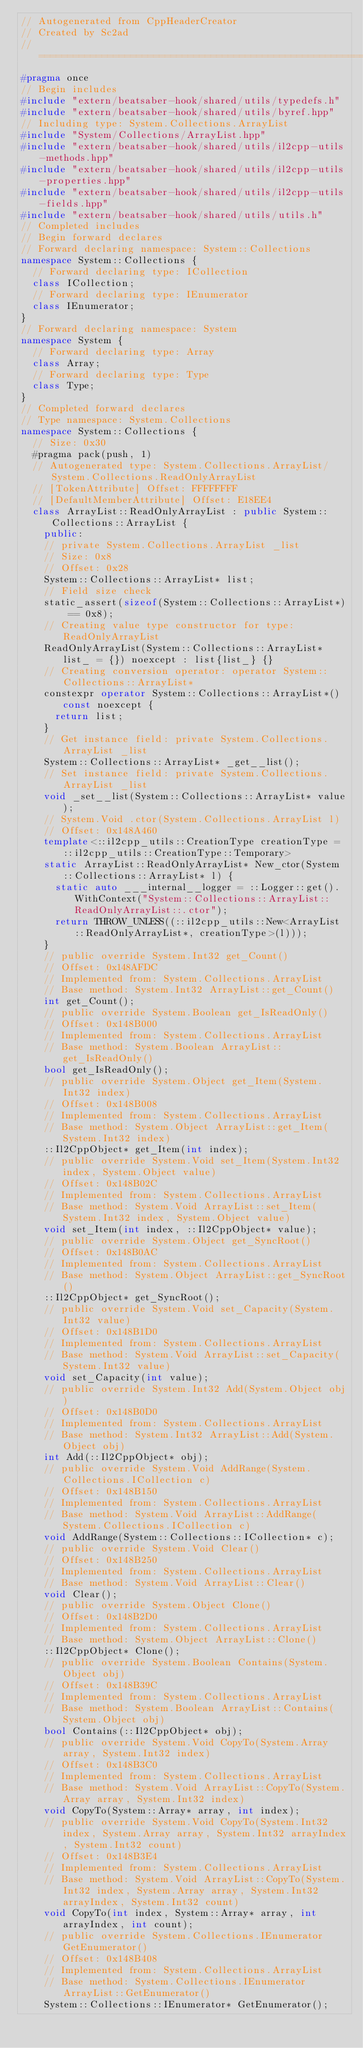Convert code to text. <code><loc_0><loc_0><loc_500><loc_500><_C++_>// Autogenerated from CppHeaderCreator
// Created by Sc2ad
// =========================================================================
#pragma once
// Begin includes
#include "extern/beatsaber-hook/shared/utils/typedefs.h"
#include "extern/beatsaber-hook/shared/utils/byref.hpp"
// Including type: System.Collections.ArrayList
#include "System/Collections/ArrayList.hpp"
#include "extern/beatsaber-hook/shared/utils/il2cpp-utils-methods.hpp"
#include "extern/beatsaber-hook/shared/utils/il2cpp-utils-properties.hpp"
#include "extern/beatsaber-hook/shared/utils/il2cpp-utils-fields.hpp"
#include "extern/beatsaber-hook/shared/utils/utils.h"
// Completed includes
// Begin forward declares
// Forward declaring namespace: System::Collections
namespace System::Collections {
  // Forward declaring type: ICollection
  class ICollection;
  // Forward declaring type: IEnumerator
  class IEnumerator;
}
// Forward declaring namespace: System
namespace System {
  // Forward declaring type: Array
  class Array;
  // Forward declaring type: Type
  class Type;
}
// Completed forward declares
// Type namespace: System.Collections
namespace System::Collections {
  // Size: 0x30
  #pragma pack(push, 1)
  // Autogenerated type: System.Collections.ArrayList/System.Collections.ReadOnlyArrayList
  // [TokenAttribute] Offset: FFFFFFFF
  // [DefaultMemberAttribute] Offset: E18EE4
  class ArrayList::ReadOnlyArrayList : public System::Collections::ArrayList {
    public:
    // private System.Collections.ArrayList _list
    // Size: 0x8
    // Offset: 0x28
    System::Collections::ArrayList* list;
    // Field size check
    static_assert(sizeof(System::Collections::ArrayList*) == 0x8);
    // Creating value type constructor for type: ReadOnlyArrayList
    ReadOnlyArrayList(System::Collections::ArrayList* list_ = {}) noexcept : list{list_} {}
    // Creating conversion operator: operator System::Collections::ArrayList*
    constexpr operator System::Collections::ArrayList*() const noexcept {
      return list;
    }
    // Get instance field: private System.Collections.ArrayList _list
    System::Collections::ArrayList* _get__list();
    // Set instance field: private System.Collections.ArrayList _list
    void _set__list(System::Collections::ArrayList* value);
    // System.Void .ctor(System.Collections.ArrayList l)
    // Offset: 0x148A460
    template<::il2cpp_utils::CreationType creationType = ::il2cpp_utils::CreationType::Temporary>
    static ArrayList::ReadOnlyArrayList* New_ctor(System::Collections::ArrayList* l) {
      static auto ___internal__logger = ::Logger::get().WithContext("System::Collections::ArrayList::ReadOnlyArrayList::.ctor");
      return THROW_UNLESS((::il2cpp_utils::New<ArrayList::ReadOnlyArrayList*, creationType>(l)));
    }
    // public override System.Int32 get_Count()
    // Offset: 0x148AFDC
    // Implemented from: System.Collections.ArrayList
    // Base method: System.Int32 ArrayList::get_Count()
    int get_Count();
    // public override System.Boolean get_IsReadOnly()
    // Offset: 0x148B000
    // Implemented from: System.Collections.ArrayList
    // Base method: System.Boolean ArrayList::get_IsReadOnly()
    bool get_IsReadOnly();
    // public override System.Object get_Item(System.Int32 index)
    // Offset: 0x148B008
    // Implemented from: System.Collections.ArrayList
    // Base method: System.Object ArrayList::get_Item(System.Int32 index)
    ::Il2CppObject* get_Item(int index);
    // public override System.Void set_Item(System.Int32 index, System.Object value)
    // Offset: 0x148B02C
    // Implemented from: System.Collections.ArrayList
    // Base method: System.Void ArrayList::set_Item(System.Int32 index, System.Object value)
    void set_Item(int index, ::Il2CppObject* value);
    // public override System.Object get_SyncRoot()
    // Offset: 0x148B0AC
    // Implemented from: System.Collections.ArrayList
    // Base method: System.Object ArrayList::get_SyncRoot()
    ::Il2CppObject* get_SyncRoot();
    // public override System.Void set_Capacity(System.Int32 value)
    // Offset: 0x148B1D0
    // Implemented from: System.Collections.ArrayList
    // Base method: System.Void ArrayList::set_Capacity(System.Int32 value)
    void set_Capacity(int value);
    // public override System.Int32 Add(System.Object obj)
    // Offset: 0x148B0D0
    // Implemented from: System.Collections.ArrayList
    // Base method: System.Int32 ArrayList::Add(System.Object obj)
    int Add(::Il2CppObject* obj);
    // public override System.Void AddRange(System.Collections.ICollection c)
    // Offset: 0x148B150
    // Implemented from: System.Collections.ArrayList
    // Base method: System.Void ArrayList::AddRange(System.Collections.ICollection c)
    void AddRange(System::Collections::ICollection* c);
    // public override System.Void Clear()
    // Offset: 0x148B250
    // Implemented from: System.Collections.ArrayList
    // Base method: System.Void ArrayList::Clear()
    void Clear();
    // public override System.Object Clone()
    // Offset: 0x148B2D0
    // Implemented from: System.Collections.ArrayList
    // Base method: System.Object ArrayList::Clone()
    ::Il2CppObject* Clone();
    // public override System.Boolean Contains(System.Object obj)
    // Offset: 0x148B39C
    // Implemented from: System.Collections.ArrayList
    // Base method: System.Boolean ArrayList::Contains(System.Object obj)
    bool Contains(::Il2CppObject* obj);
    // public override System.Void CopyTo(System.Array array, System.Int32 index)
    // Offset: 0x148B3C0
    // Implemented from: System.Collections.ArrayList
    // Base method: System.Void ArrayList::CopyTo(System.Array array, System.Int32 index)
    void CopyTo(System::Array* array, int index);
    // public override System.Void CopyTo(System.Int32 index, System.Array array, System.Int32 arrayIndex, System.Int32 count)
    // Offset: 0x148B3E4
    // Implemented from: System.Collections.ArrayList
    // Base method: System.Void ArrayList::CopyTo(System.Int32 index, System.Array array, System.Int32 arrayIndex, System.Int32 count)
    void CopyTo(int index, System::Array* array, int arrayIndex, int count);
    // public override System.Collections.IEnumerator GetEnumerator()
    // Offset: 0x148B408
    // Implemented from: System.Collections.ArrayList
    // Base method: System.Collections.IEnumerator ArrayList::GetEnumerator()
    System::Collections::IEnumerator* GetEnumerator();</code> 